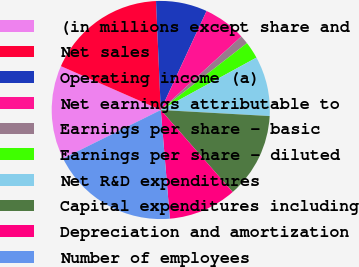Convert chart. <chart><loc_0><loc_0><loc_500><loc_500><pie_chart><fcel>(in millions except share and<fcel>Net sales<fcel>Operating income (a)<fcel>Net earnings attributable to<fcel>Earnings per share - basic<fcel>Earnings per share - diluted<fcel>Net R&D expenditures<fcel>Capital expenditures including<fcel>Depreciation and amortization<fcel>Number of employees<nl><fcel>13.92%<fcel>17.72%<fcel>7.59%<fcel>6.33%<fcel>1.27%<fcel>2.53%<fcel>8.86%<fcel>12.66%<fcel>10.13%<fcel>18.99%<nl></chart> 